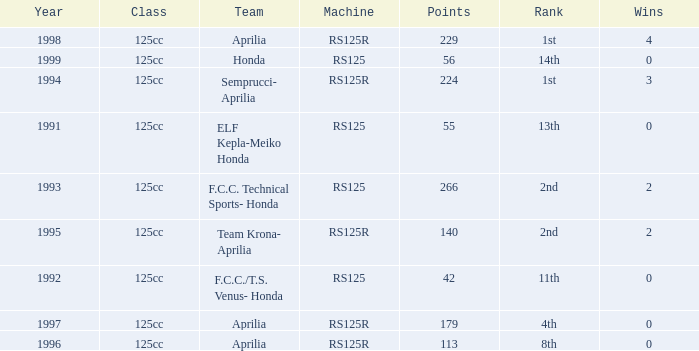Which year had a team of Aprilia and a rank of 4th? 1997.0. 